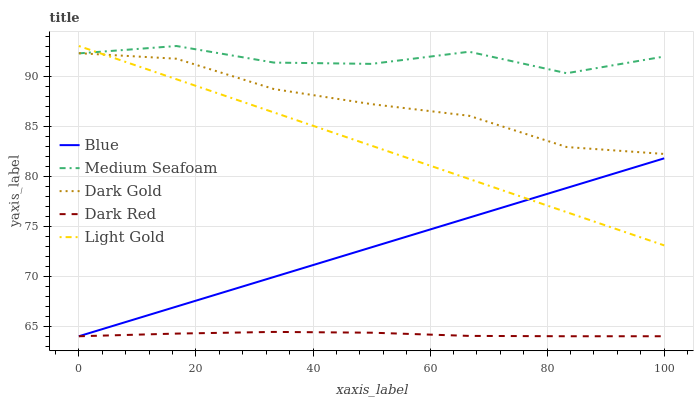Does Dark Red have the minimum area under the curve?
Answer yes or no. Yes. Does Medium Seafoam have the maximum area under the curve?
Answer yes or no. Yes. Does Light Gold have the minimum area under the curve?
Answer yes or no. No. Does Light Gold have the maximum area under the curve?
Answer yes or no. No. Is Blue the smoothest?
Answer yes or no. Yes. Is Medium Seafoam the roughest?
Answer yes or no. Yes. Is Dark Red the smoothest?
Answer yes or no. No. Is Dark Red the roughest?
Answer yes or no. No. Does Light Gold have the lowest value?
Answer yes or no. No. Does Medium Seafoam have the highest value?
Answer yes or no. Yes. Does Dark Red have the highest value?
Answer yes or no. No. Is Dark Red less than Medium Seafoam?
Answer yes or no. Yes. Is Light Gold greater than Dark Red?
Answer yes or no. Yes. Does Dark Red intersect Medium Seafoam?
Answer yes or no. No. 